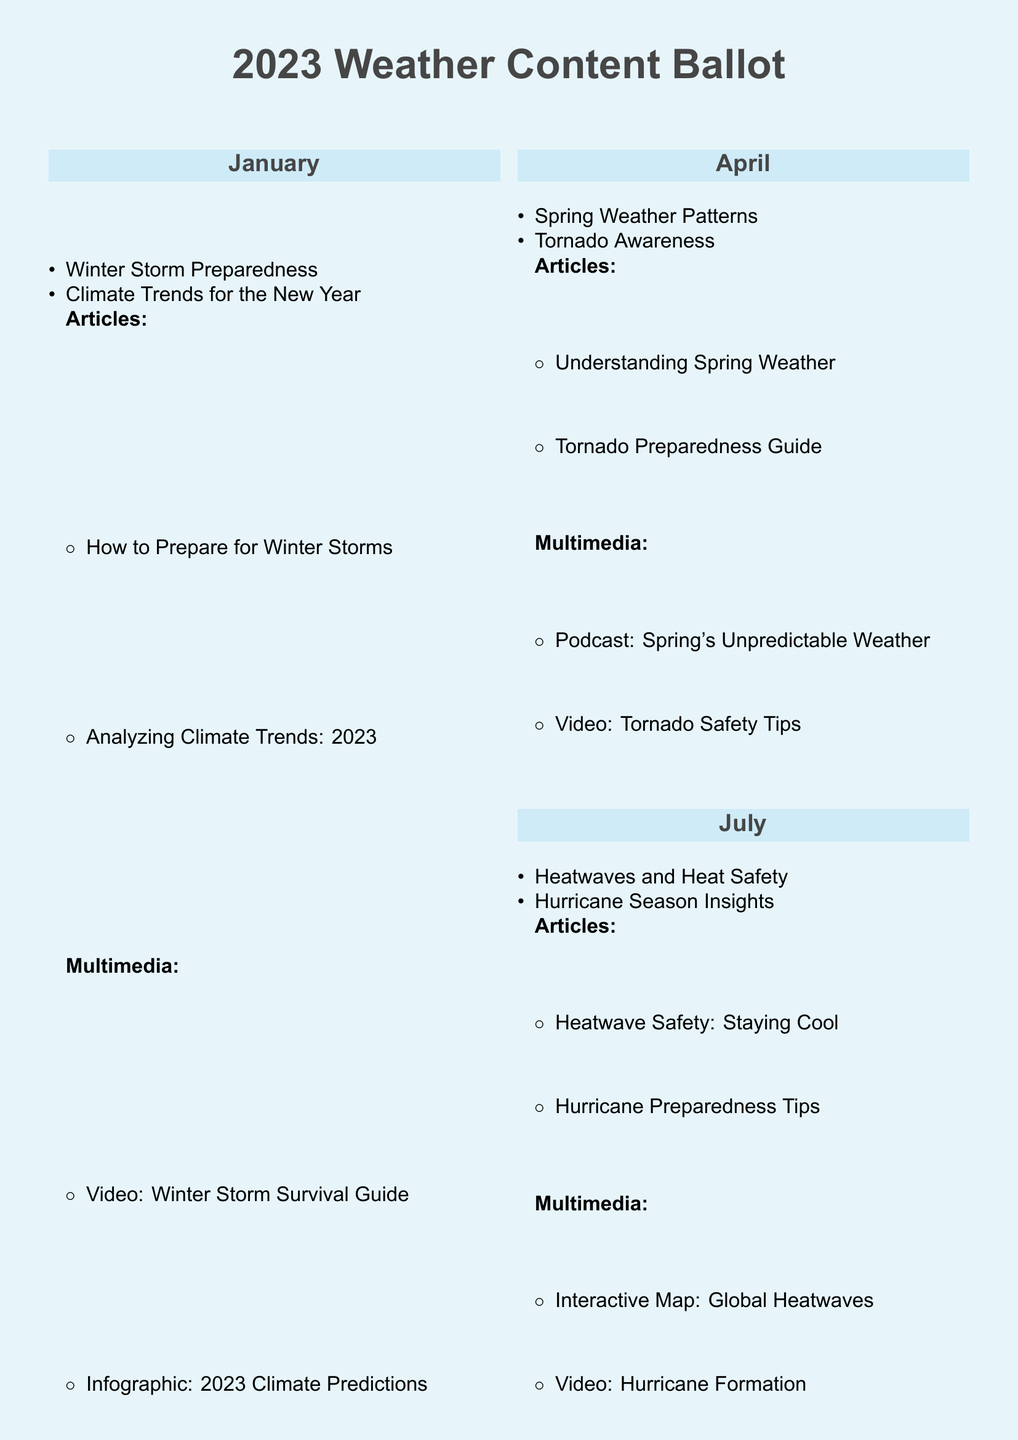What is the title of the ballot? The title of the ballot is clearly stated at the top of the document as "2023 Weather Content Ballot."
Answer: 2023 Weather Content Ballot Which month covers the topic of winter storm preparedness? The month that covers winter storm preparedness is January.
Answer: January How many multimedia content pieces are suggested for the month of April? The document lists two multimedia pieces for April: a podcast and a video, making it a total of two.
Answer: 2 What article discusses the evolution of storm tracking? The article titled "Evolution of Storm Tracking" is included in the October section of the ballot.
Answer: Evolution of Storm Tracking What is one of the multimedia content types suggested for July? For July, one multimedia content type suggested is a video. Specifically, it is related to hurricane formation.
Answer: Video How many articles are suggested for the month of January? In January, there are two articles suggested: "How to Prepare for Winter Storms" and "Analyzing Climate Trends: 2023," totaling two articles.
Answer: 2 What is the focus of the multimedia content suggested for October? The multimedia content suggested for October includes an infographic and a podcast discussing storm tracking.
Answer: Infographic and Podcast Which month includes discussions about tornado awareness? Tornado awareness is discussed in the month of April.
Answer: April What type of content is represented by "Interactive Map" in July? The "Interactive Map" is a type of multimedia content suggested for July.
Answer: Interactive Map 